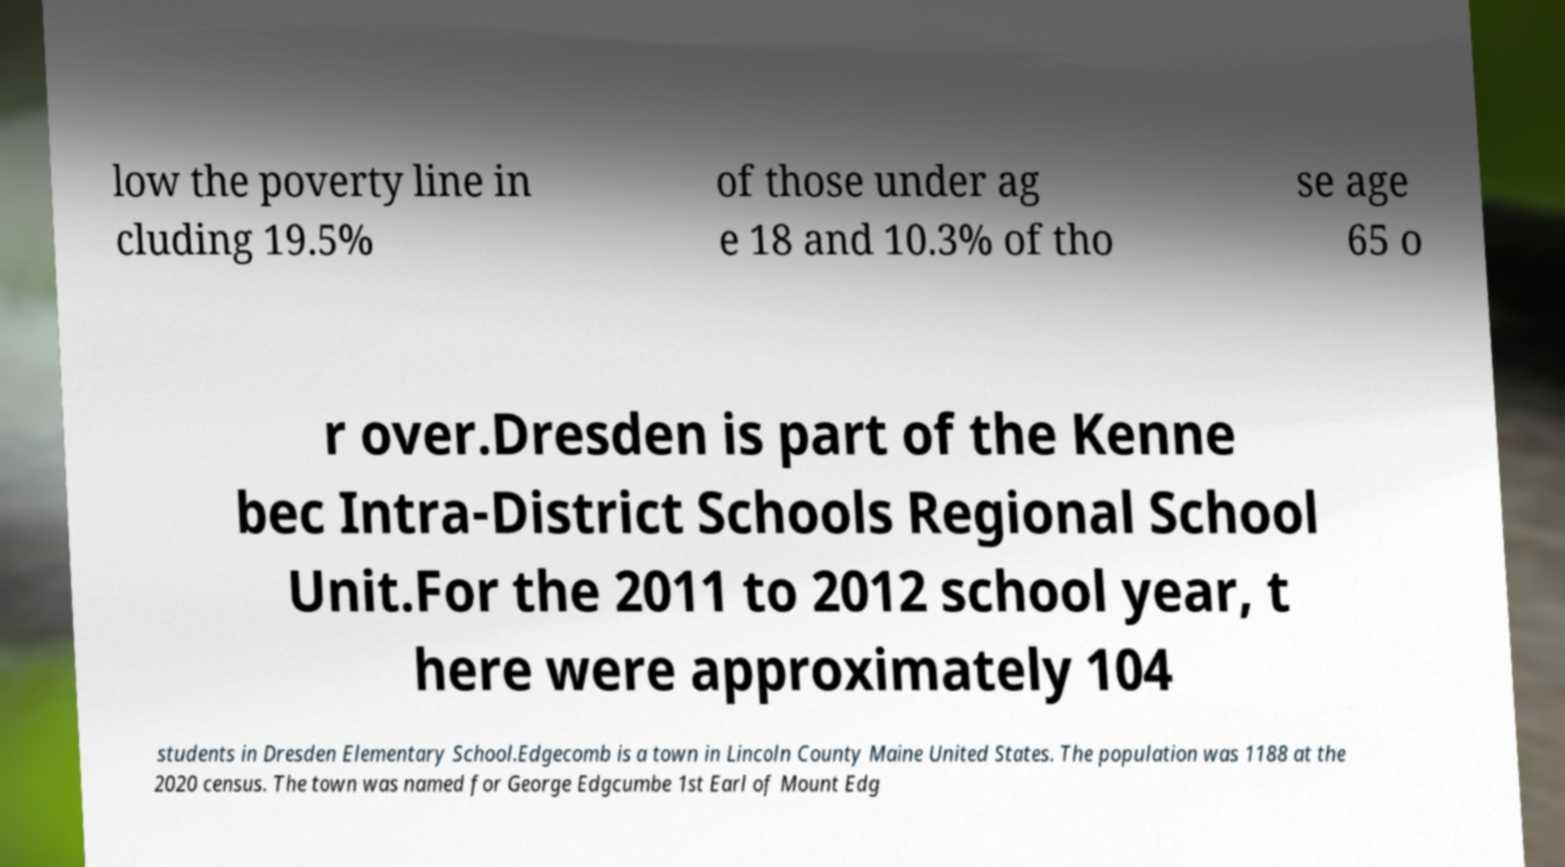Can you accurately transcribe the text from the provided image for me? low the poverty line in cluding 19.5% of those under ag e 18 and 10.3% of tho se age 65 o r over.Dresden is part of the Kenne bec Intra-District Schools Regional School Unit.For the 2011 to 2012 school year, t here were approximately 104 students in Dresden Elementary School.Edgecomb is a town in Lincoln County Maine United States. The population was 1188 at the 2020 census. The town was named for George Edgcumbe 1st Earl of Mount Edg 